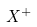Convert formula to latex. <formula><loc_0><loc_0><loc_500><loc_500>X ^ { + }</formula> 